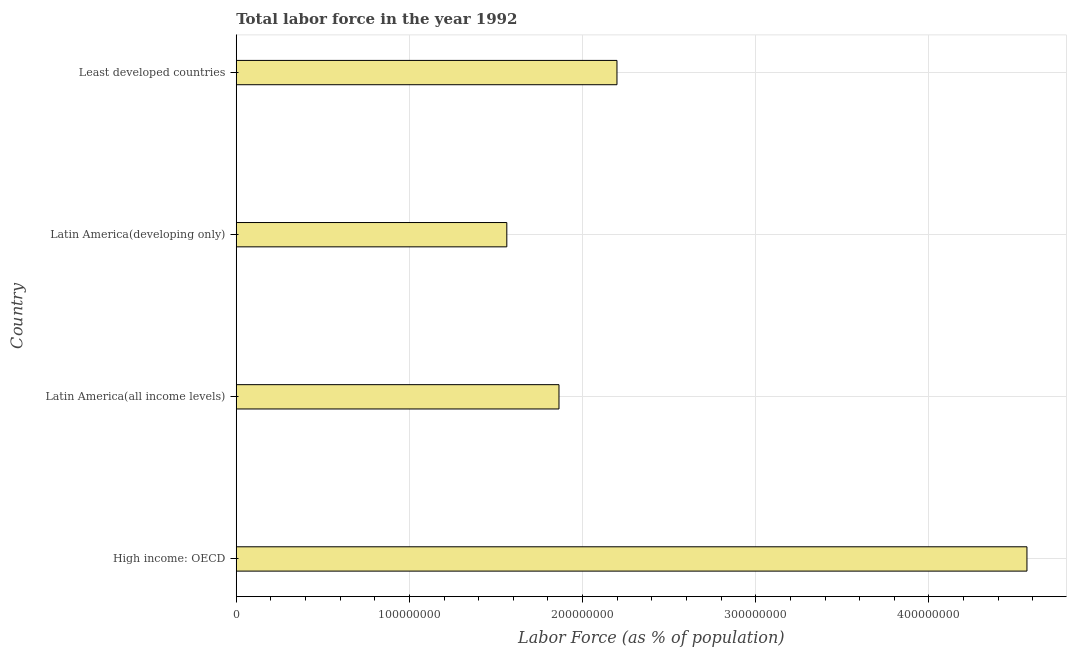What is the title of the graph?
Offer a terse response. Total labor force in the year 1992. What is the label or title of the X-axis?
Your response must be concise. Labor Force (as % of population). What is the label or title of the Y-axis?
Provide a succinct answer. Country. What is the total labor force in Latin America(all income levels)?
Make the answer very short. 1.86e+08. Across all countries, what is the maximum total labor force?
Provide a short and direct response. 4.57e+08. Across all countries, what is the minimum total labor force?
Provide a succinct answer. 1.56e+08. In which country was the total labor force maximum?
Offer a very short reply. High income: OECD. In which country was the total labor force minimum?
Your response must be concise. Latin America(developing only). What is the sum of the total labor force?
Your answer should be very brief. 1.02e+09. What is the difference between the total labor force in High income: OECD and Latin America(all income levels)?
Provide a succinct answer. 2.70e+08. What is the average total labor force per country?
Make the answer very short. 2.55e+08. What is the median total labor force?
Provide a short and direct response. 2.03e+08. What is the ratio of the total labor force in High income: OECD to that in Least developed countries?
Your response must be concise. 2.08. Is the difference between the total labor force in High income: OECD and Latin America(all income levels) greater than the difference between any two countries?
Offer a very short reply. No. What is the difference between the highest and the second highest total labor force?
Your answer should be very brief. 2.37e+08. What is the difference between the highest and the lowest total labor force?
Give a very brief answer. 3.00e+08. Are all the bars in the graph horizontal?
Your answer should be compact. Yes. How many countries are there in the graph?
Your answer should be compact. 4. What is the Labor Force (as % of population) in High income: OECD?
Your answer should be compact. 4.57e+08. What is the Labor Force (as % of population) of Latin America(all income levels)?
Make the answer very short. 1.86e+08. What is the Labor Force (as % of population) in Latin America(developing only)?
Offer a terse response. 1.56e+08. What is the Labor Force (as % of population) of Least developed countries?
Your answer should be very brief. 2.20e+08. What is the difference between the Labor Force (as % of population) in High income: OECD and Latin America(all income levels)?
Offer a very short reply. 2.70e+08. What is the difference between the Labor Force (as % of population) in High income: OECD and Latin America(developing only)?
Keep it short and to the point. 3.00e+08. What is the difference between the Labor Force (as % of population) in High income: OECD and Least developed countries?
Ensure brevity in your answer.  2.37e+08. What is the difference between the Labor Force (as % of population) in Latin America(all income levels) and Latin America(developing only)?
Provide a succinct answer. 3.01e+07. What is the difference between the Labor Force (as % of population) in Latin America(all income levels) and Least developed countries?
Provide a short and direct response. -3.35e+07. What is the difference between the Labor Force (as % of population) in Latin America(developing only) and Least developed countries?
Your answer should be compact. -6.36e+07. What is the ratio of the Labor Force (as % of population) in High income: OECD to that in Latin America(all income levels)?
Keep it short and to the point. 2.45. What is the ratio of the Labor Force (as % of population) in High income: OECD to that in Latin America(developing only)?
Make the answer very short. 2.92. What is the ratio of the Labor Force (as % of population) in High income: OECD to that in Least developed countries?
Provide a succinct answer. 2.08. What is the ratio of the Labor Force (as % of population) in Latin America(all income levels) to that in Latin America(developing only)?
Your response must be concise. 1.19. What is the ratio of the Labor Force (as % of population) in Latin America(all income levels) to that in Least developed countries?
Keep it short and to the point. 0.85. What is the ratio of the Labor Force (as % of population) in Latin America(developing only) to that in Least developed countries?
Offer a very short reply. 0.71. 